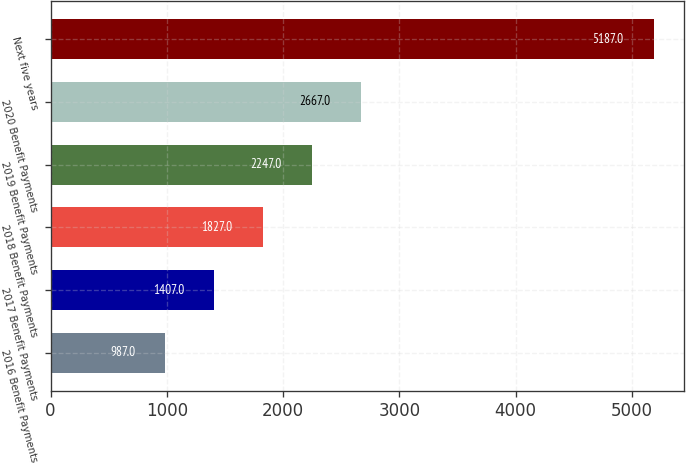Convert chart to OTSL. <chart><loc_0><loc_0><loc_500><loc_500><bar_chart><fcel>2016 Benefit Payments<fcel>2017 Benefit Payments<fcel>2018 Benefit Payments<fcel>2019 Benefit Payments<fcel>2020 Benefit Payments<fcel>Next five years<nl><fcel>987<fcel>1407<fcel>1827<fcel>2247<fcel>2667<fcel>5187<nl></chart> 